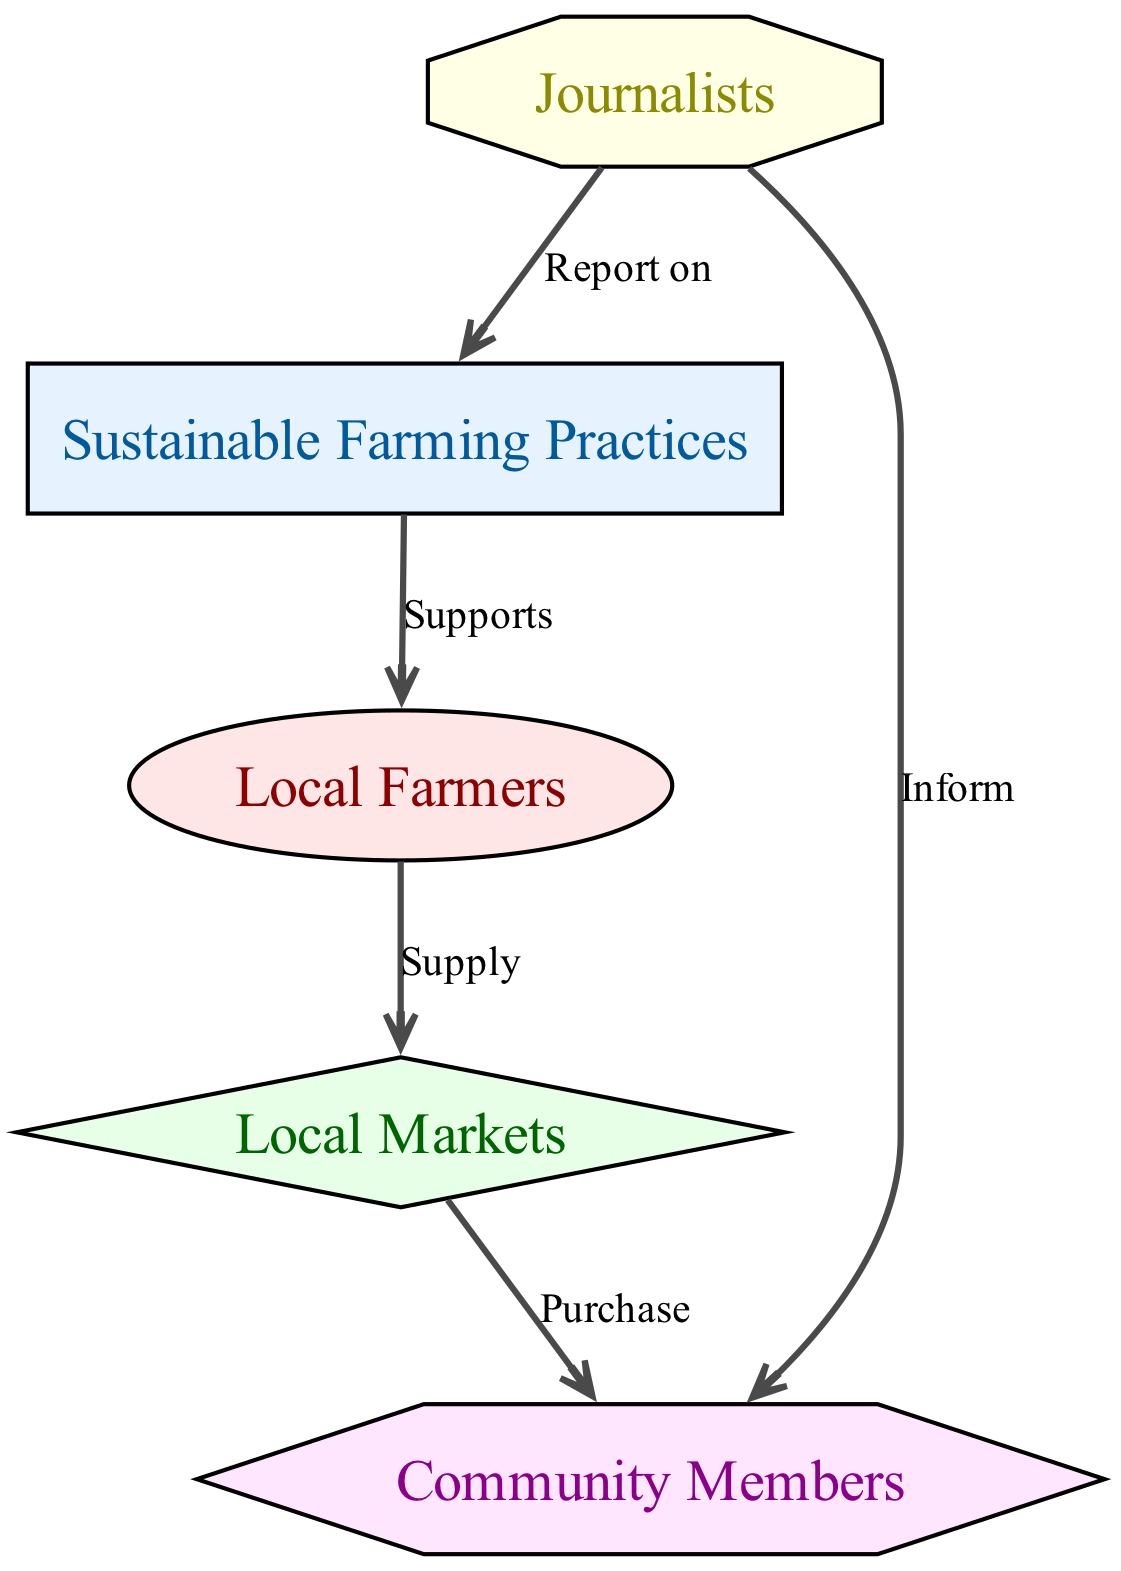What is the first node in the food chain? The first node in the food chain represents the source of energy, which is "Sustainable Farming Practices." This node is identified as the producer in the diagram.
Answer: Sustainable Farming Practices How many primary consumers are there? The diagram indicates there is only one primary consumer, which is "Local Farmers." This is clearly labeled in the node category.
Answer: 1 What connects "Local Farmers" and "Local Markets"? The relationship between "Local Farmers" and "Local Markets" is defined by the edge labeled "Supply," which indicates the movement of goods from farmers to markets.
Answer: Supply Which node receives reports from journalists? The node that receives reports from journalists is "Sustainable Farming Practices," as denoted by the edge labeled "Report on" which directs from journalists to this practice.
Answer: Sustainable Farming Practices What type of consumer are "Community Members"? "Community Members" are categorized as tertiary consumers in the food chain, indicated by their shape and color in the diagram.
Answer: Tertiary consumer What is the last action taken by journalists towards the community? Journalists "Inform" community members as represented by the edge directed from journalists to community members. This action highlights the role of journalists in educating the community.
Answer: Inform How do sustainable farming practices impact local farmers? Sustainable farming practices support local farmers, as marked by the "Supports" edge that flows from sustainable practices to the local farmers, indicating a direct effect.
Answer: Supports What is the relationship between "Local Markets" and "Community Members"? The relationship is dictated by the action "Purchase," which establishes that community members buy from local markets, forming a direct economic connection.
Answer: Purchase What is the total number of edges in the diagram? By counting all the explicit connections made between the nodes in the diagram, we find there are a total of five edges connecting the various entities.
Answer: 5 